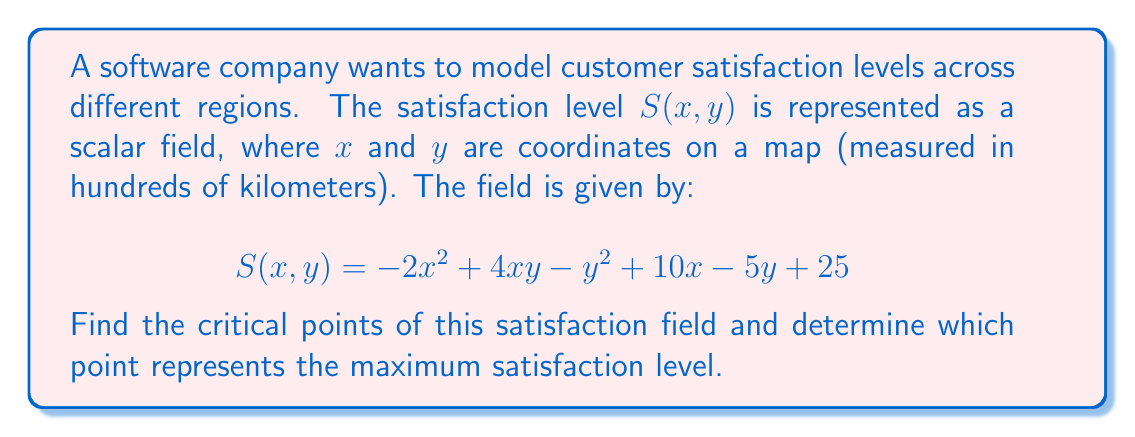Could you help me with this problem? To find the critical points of the scalar field $S(x,y)$, we need to follow these steps:

1) Calculate the partial derivatives of $S$ with respect to $x$ and $y$:

   $$\frac{\partial S}{\partial x} = -4x + 4y + 10$$
   $$\frac{\partial S}{\partial y} = 4x - 2y - 5$$

2) Set both partial derivatives to zero and solve the resulting system of equations:

   $$-4x + 4y + 10 = 0 \quad (1)$$
   $$4x - 2y - 5 = 0 \quad (2)$$

3) From equation (2), express $x$ in terms of $y$:
   
   $$x = \frac{2y + 5}{4} \quad (3)$$

4) Substitute (3) into equation (1):

   $$-4(\frac{2y + 5}{4}) + 4y + 10 = 0$$
   $$-2y - 5 + 4y + 10 = 0$$
   $$2y + 5 = 0$$
   $$y = -\frac{5}{2}$$

5) Substitute this $y$ value back into equation (3):

   $$x = \frac{2(-\frac{5}{2}) + 5}{4} = \frac{5}{4}$$

6) Thus, the critical point is $(\frac{5}{4}, -\frac{5}{2})$.

7) To determine if this is a maximum, we need to calculate the Hessian matrix:

   $$H = \begin{bmatrix} 
   \frac{\partial^2 S}{\partial x^2} & \frac{\partial^2 S}{\partial x\partial y} \\
   \frac{\partial^2 S}{\partial y\partial x} & \frac{\partial^2 S}{\partial y^2}
   \end{bmatrix} = \begin{bmatrix}
   -4 & 4 \\
   4 & -2
   \end{bmatrix}$$

8) At the critical point, if the Hessian is negative definite, the point is a maximum. The determinant of $H$ is:

   $$det(H) = (-4)(-2) - (4)(4) = 8 - 16 = -8 > 0$$

   And $\frac{\partial^2 S}{\partial x^2} = -4 < 0$

Therefore, the Hessian is negative definite, confirming that the critical point is indeed a maximum.
Answer: Maximum satisfaction at $(\frac{5}{4}, -\frac{5}{2})$ 